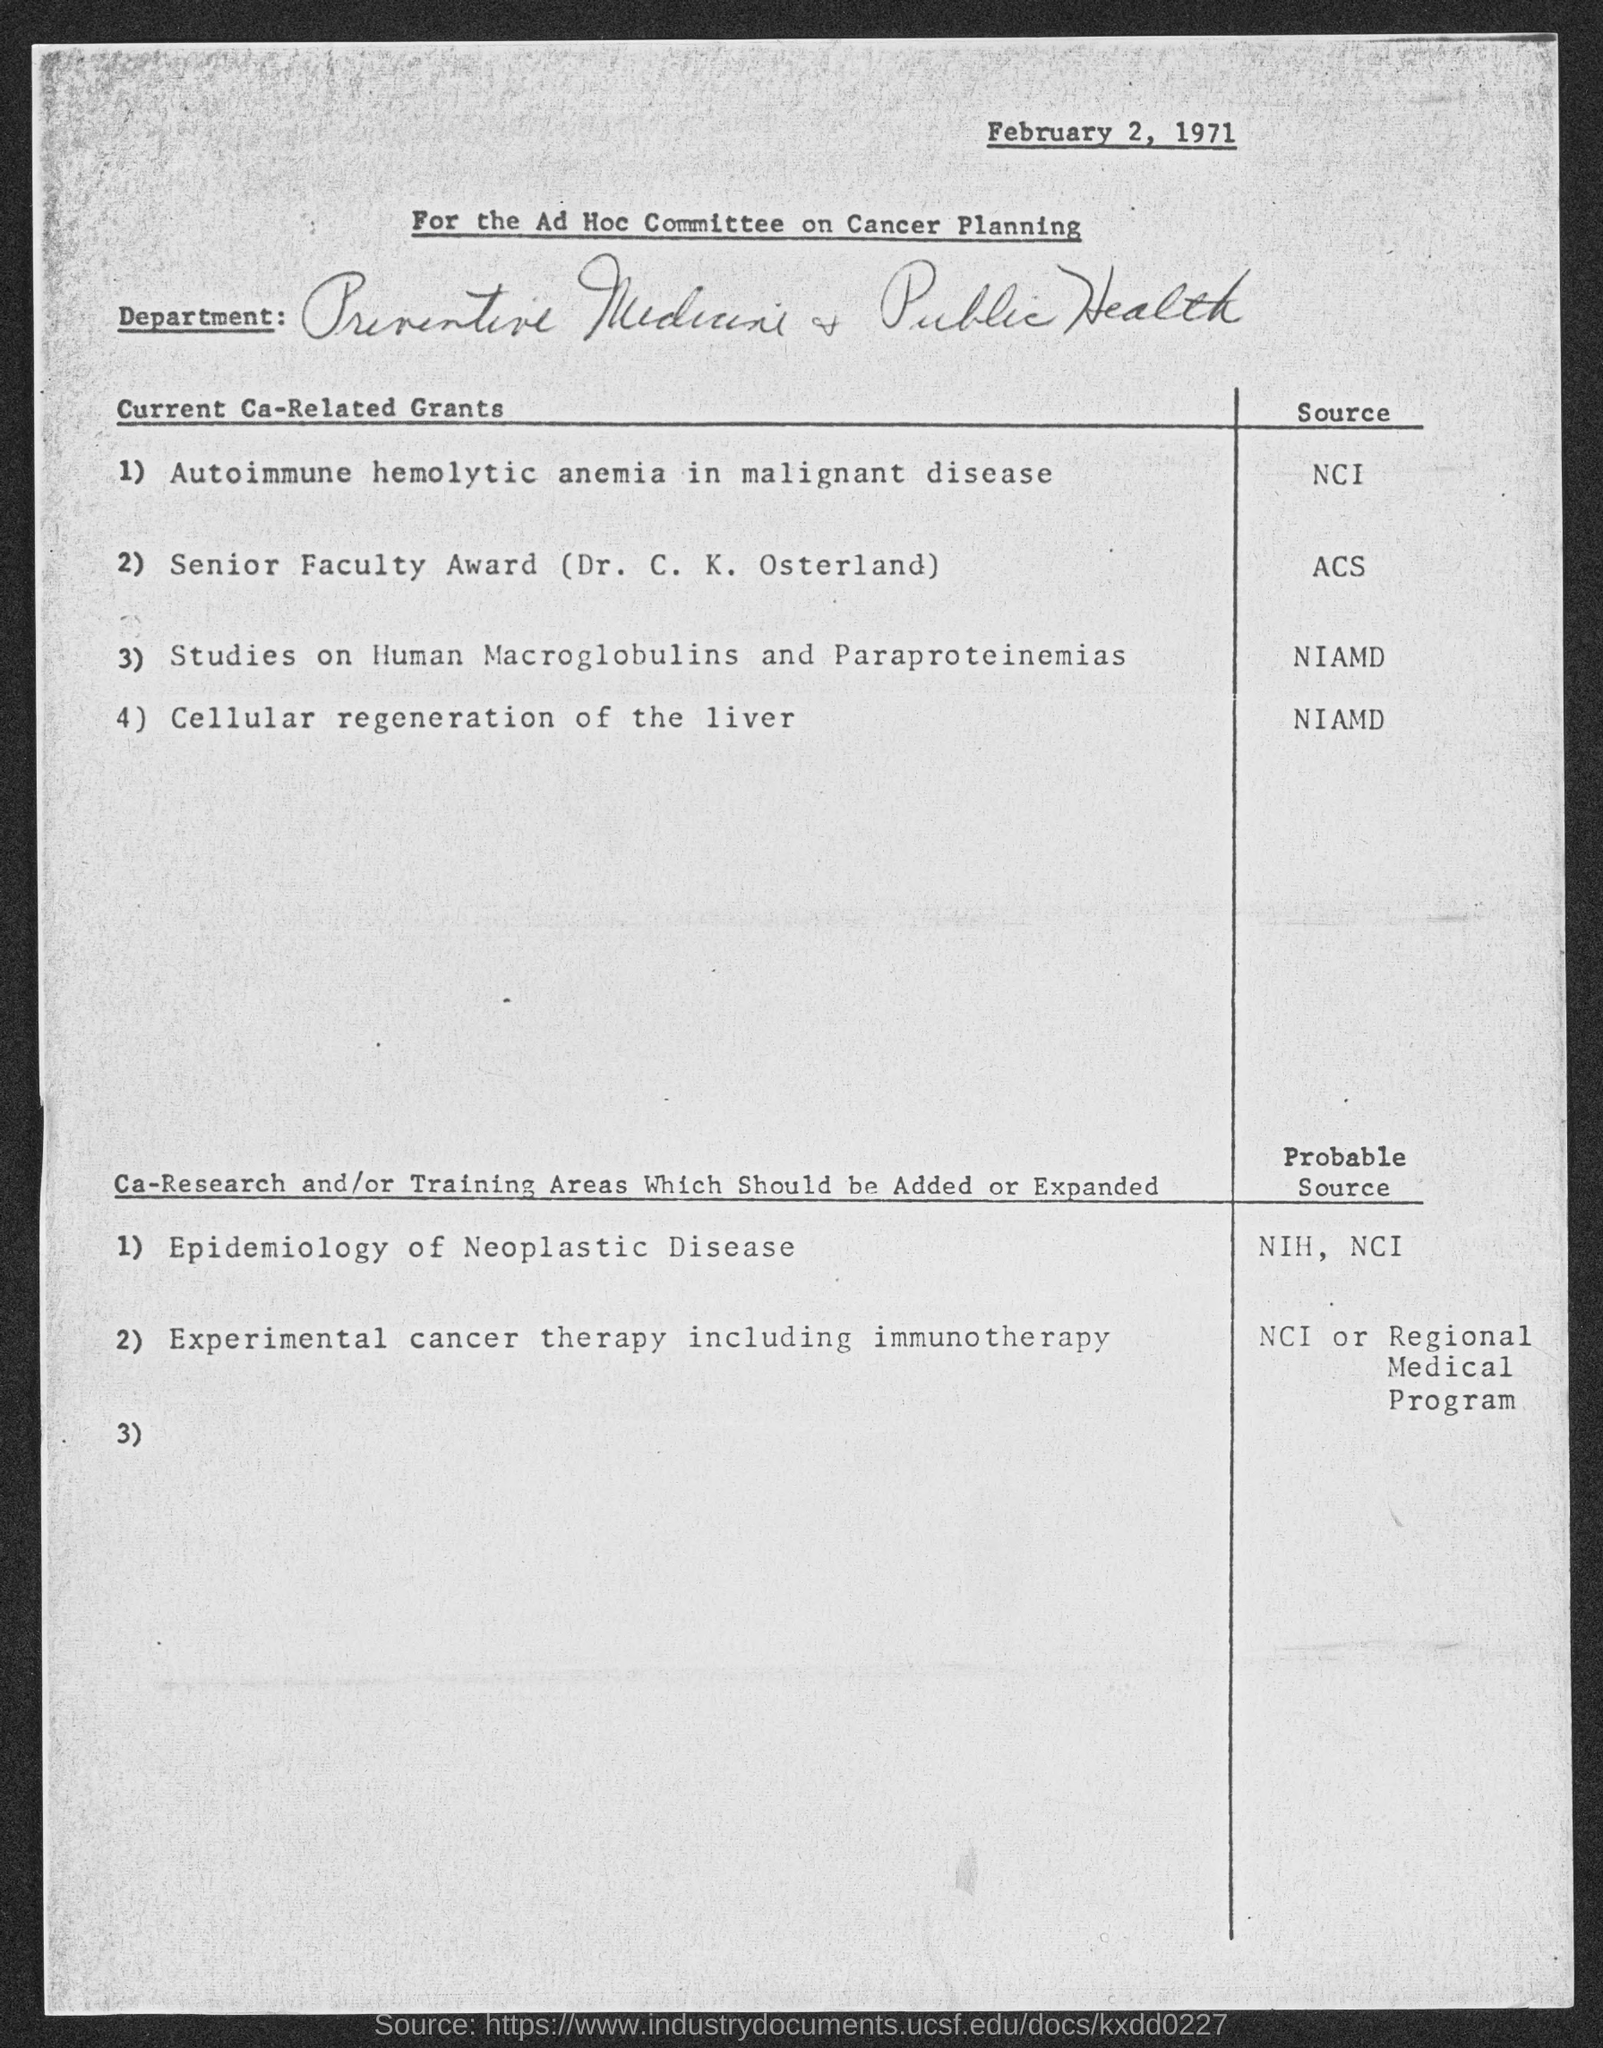What is the source for autoimmune hemolytic anemia in malignant disease, current ca- related grant?
Keep it short and to the point. NCI. What is the source for studies on human macroglobulins and paraproteinemias current ca- related grants?
Keep it short and to the point. NIAMD. What is the date at top of the page?
Your answer should be compact. February 2, 1971. 